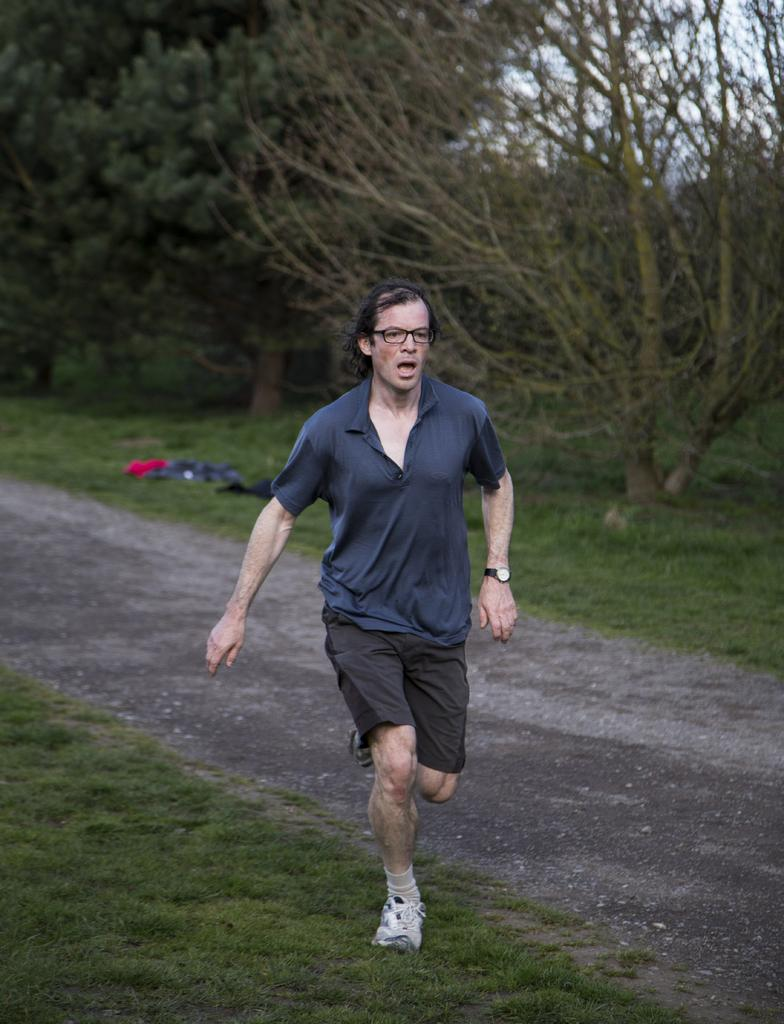What is the main subject of the image? There is a man in the image. What is the man doing in the image? The man is running in the image. Where is the man located in relation to the road? The man is near a road in the image. What color is the shirt the man is wearing? The man is wearing a blue shirt in the image. What type of surface is visible in the image? There is a grass surface in the image. What type of vegetation can be seen on the grass surface? There are dried plants on the grass surface in the image. What type of natural feature is visible in the image? There are trees visible in the image. What type of disease is the man suffering from in the image? There is no indication in the image that the man is suffering from any disease. What type of party is the man attending in the image? There is no indication in the image that the man is attending a party. 